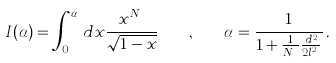Convert formula to latex. <formula><loc_0><loc_0><loc_500><loc_500>I ( \alpha ) = \int _ { 0 } ^ { \alpha } \, d x \frac { x ^ { N _ { \phi } } } { \sqrt { 1 - x } } \quad , \quad \alpha = \frac { 1 } { 1 + \frac { 1 } { N _ { \phi } } \frac { d ^ { 2 } } { 2 l _ { B } ^ { 2 } } } \, .</formula> 